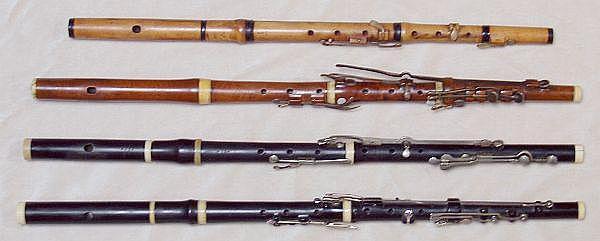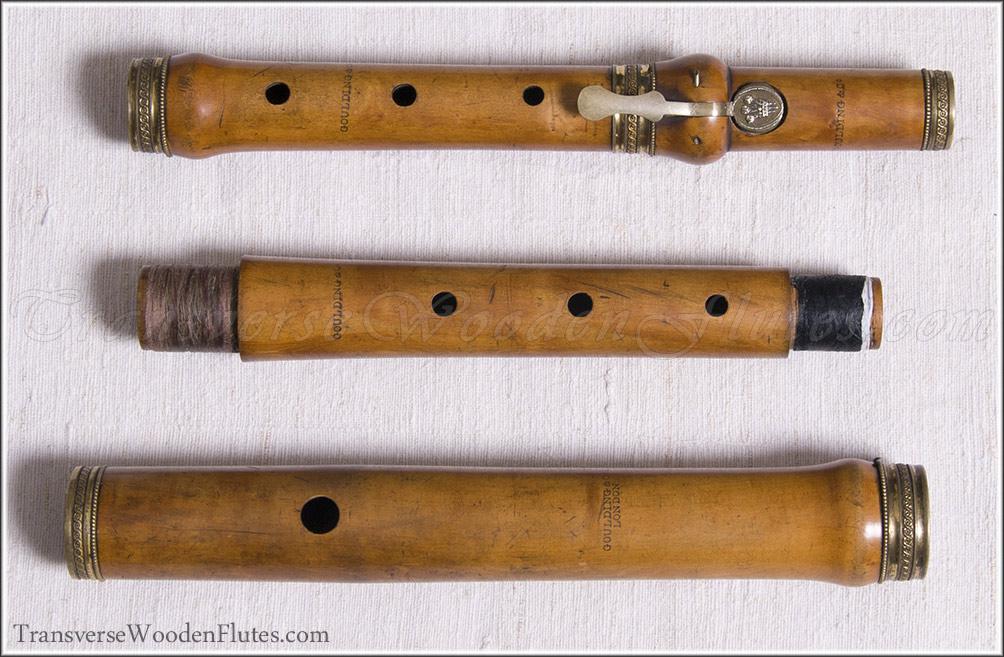The first image is the image on the left, the second image is the image on the right. Analyze the images presented: Is the assertion "In one of the images, the second flute from the bottom is a darker color than the third flute from the bottom." valid? Answer yes or no. Yes. The first image is the image on the left, the second image is the image on the right. For the images shown, is this caption "One image shows at least three flutes with metal keys displayed horizontally and parallel to one another, and the other image shows at least three rows of wooden flute parts displayed the same way." true? Answer yes or no. Yes. 